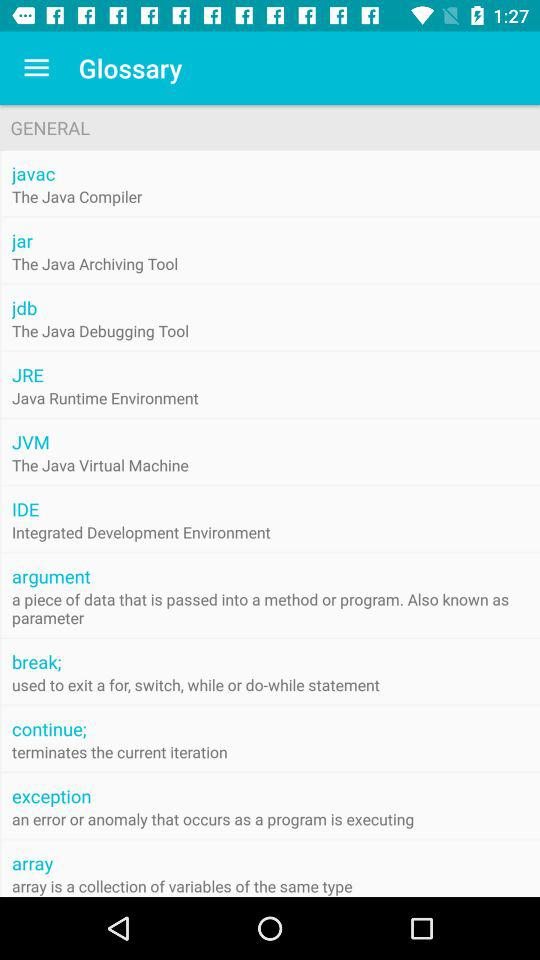What is "javac"? "javac" is the "Java Compiler". 